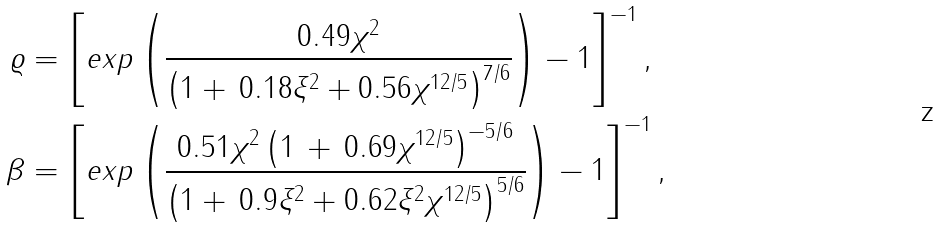<formula> <loc_0><loc_0><loc_500><loc_500>\varrho & = \left [ e x p \left ( \frac { 0 . 4 9 \chi ^ { 2 } } { \left ( 1 + \, 0 . 1 8 \xi ^ { 2 } + 0 . 5 6 \chi ^ { 1 2 / 5 } \right ) ^ { 7 / 6 } } \right ) - 1 \right ] ^ { - 1 } , \\ \beta & = \left [ e x p \left ( \frac { 0 . 5 1 \chi ^ { 2 } \left ( 1 \, + \, 0 . 6 9 \chi ^ { 1 2 / 5 } \right ) ^ { - 5 / 6 } } { \left ( 1 + \, 0 . 9 \xi ^ { 2 } + 0 . 6 2 \xi ^ { 2 } \chi ^ { 1 2 / 5 } \right ) ^ { 5 / 6 } } \right ) - 1 \right ] ^ { - 1 } ,</formula> 